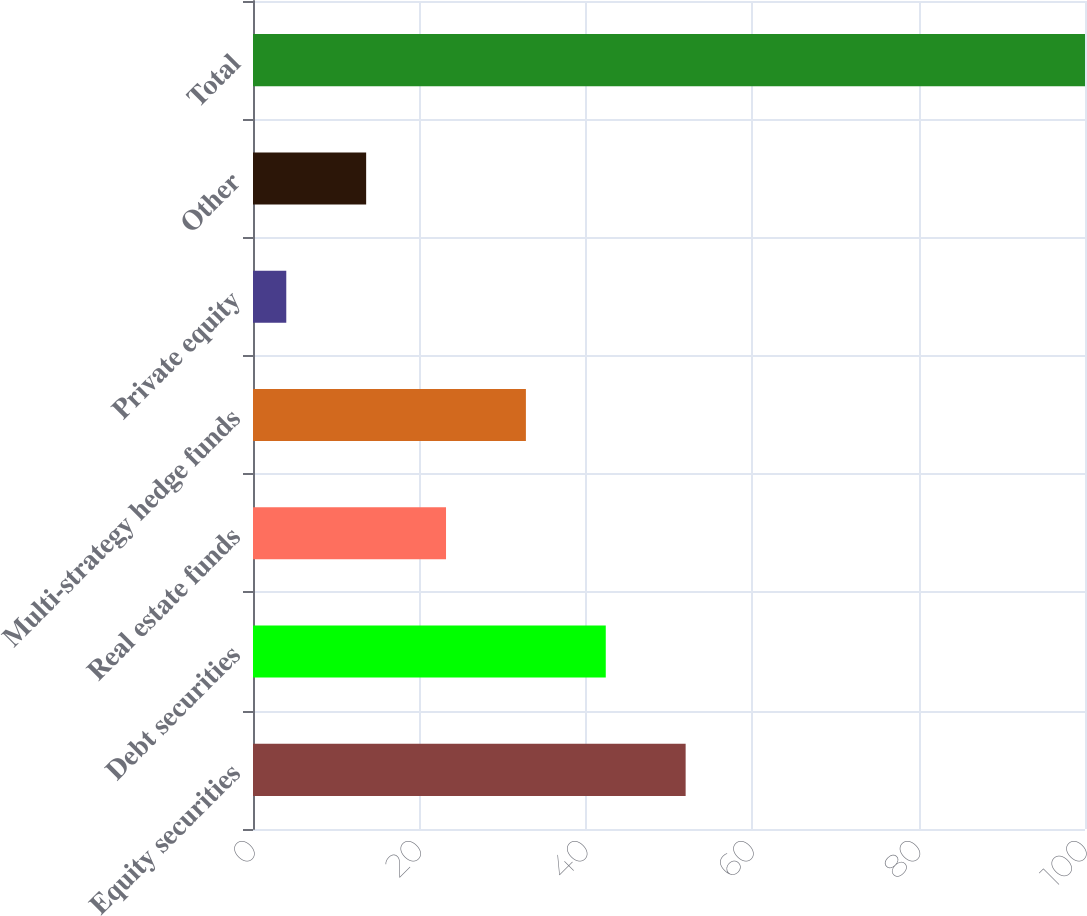<chart> <loc_0><loc_0><loc_500><loc_500><bar_chart><fcel>Equity securities<fcel>Debt securities<fcel>Real estate funds<fcel>Multi-strategy hedge funds<fcel>Private equity<fcel>Other<fcel>Total<nl><fcel>52<fcel>42.4<fcel>23.2<fcel>32.8<fcel>4<fcel>13.6<fcel>100<nl></chart> 